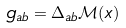<formula> <loc_0><loc_0><loc_500><loc_500>g _ { a b } = \Delta _ { a b } { \mathcal { M } } ( x )</formula> 